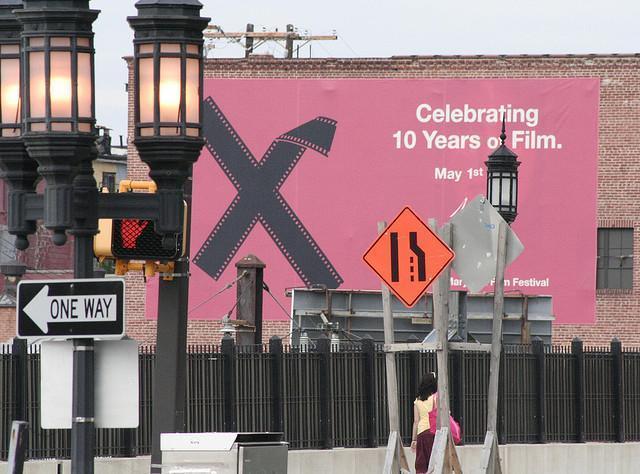How many cows are to the left of the person in the middle?
Give a very brief answer. 0. 